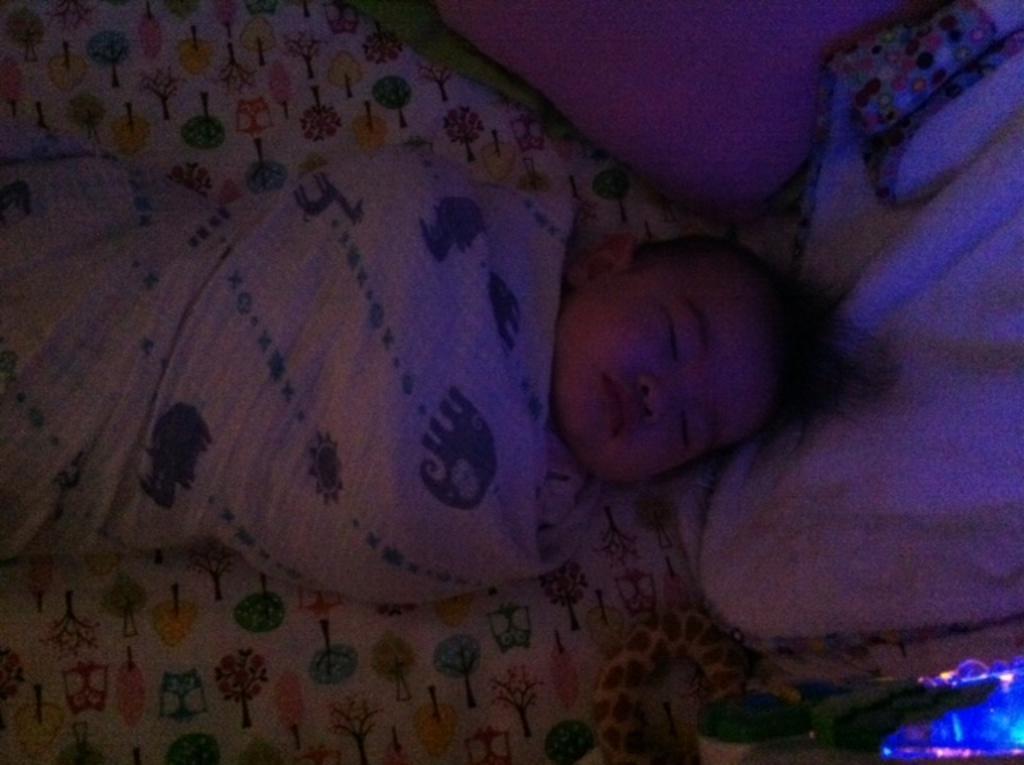Please provide a concise description of this image. In the image we can see a baby sleeping and the baby is wrapped in a cloth. Here we can see a toy and pillow. 